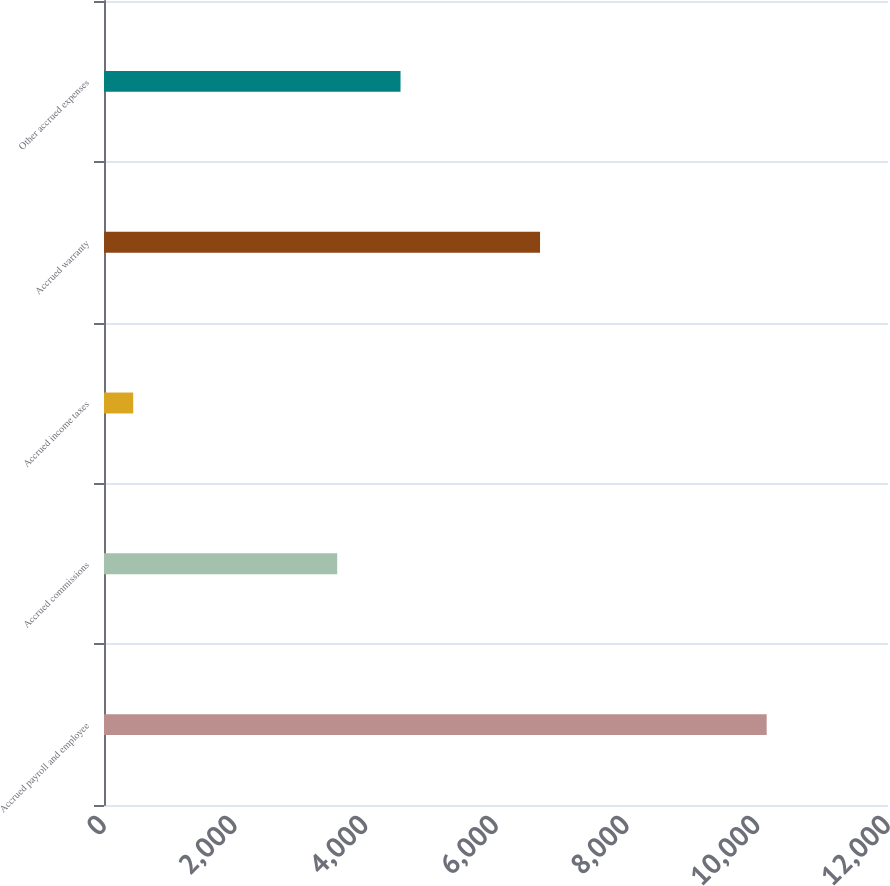Convert chart. <chart><loc_0><loc_0><loc_500><loc_500><bar_chart><fcel>Accrued payroll and employee<fcel>Accrued commissions<fcel>Accrued income taxes<fcel>Accrued warranty<fcel>Other accrued expenses<nl><fcel>10143<fcel>3569<fcel>447<fcel>6674<fcel>4538.6<nl></chart> 